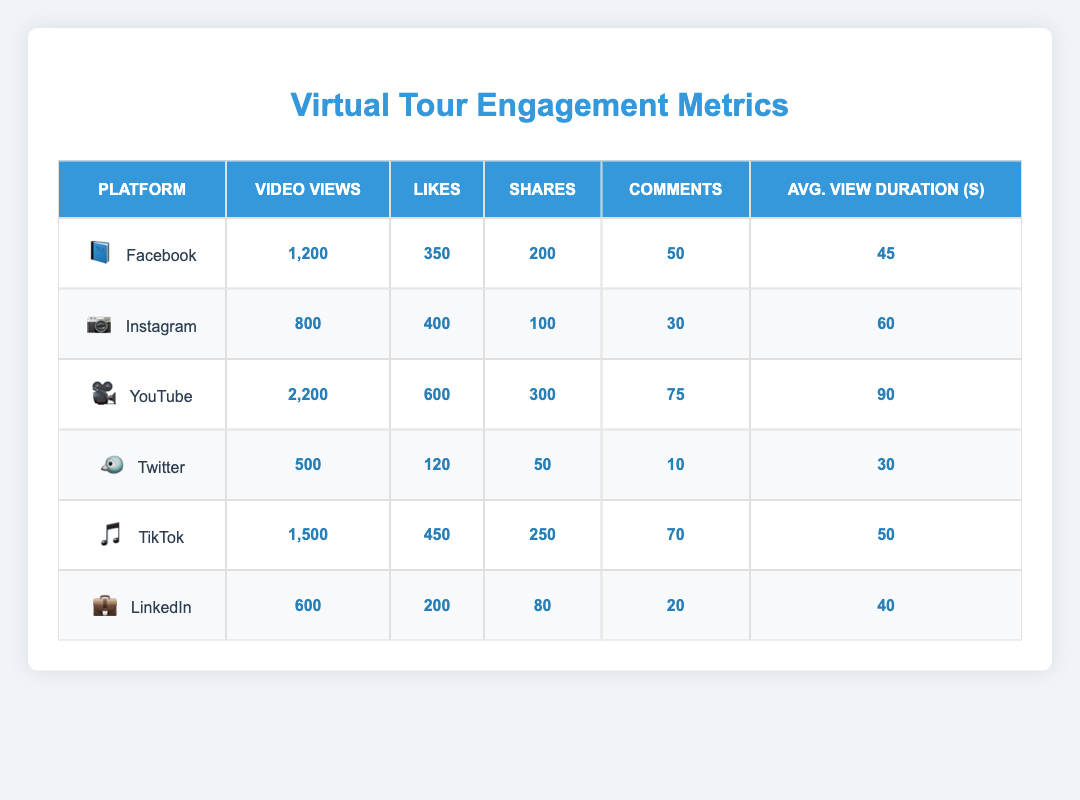What platform has the highest number of video views? By reviewing the video views for each platform listed in the table, YouTube has the highest value at 2,200 views.
Answer: YouTube What is the total number of likes across all platforms? Adding up the likes from all platforms: 350 + 400 + 600 + 120 + 450 + 200 = 2220.
Answer: 2220 Which platform has the lowest average view duration? Looking at the average view duration column, Twitter has the lowest value at 30 seconds.
Answer: Twitter How many shares does TikTok have compared to Instagram? TikTok has 250 shares and Instagram has 100 shares. The difference is 250 - 100 = 150 shares more for TikTok.
Answer: 150 more shares What is the average number of comments for all platforms combined? First, add the number of comments: 50 + 30 + 75 + 10 + 70 + 20 = 255. Then divide by the number of platforms (6): 255 / 6 = 42.5.
Answer: 42.5 Does Facebook have more likes than LinkedIn? Facebook has 350 likes while LinkedIn has 200. Since 350 is greater than 200, the answer is yes.
Answer: Yes Which platform has the highest ratio of likes to video views? Calculate the ratio for each platform: Facebook (350/1200), Instagram (400/800), YouTube (600/2200), Twitter (120/500), TikTok (450/1500), LinkedIn (200/600). After evaluating all, TikTok has the highest ratio of 0.3 (450/1500).
Answer: TikTok How does the average view duration of YouTube compare to that of Twitter? YouTube has an average view duration of 90 seconds and Twitter has 30 seconds. Comparing these values shows that YouTube's average is 60 seconds longer.
Answer: 60 seconds longer Which platform has the most shares compared to the others? By checking the shares column, YouTube has 300 shares, which is higher than all other platforms.
Answer: YouTube What is the total number of video views for Instagram and LinkedIn combined? Adding both values together: 800 (Instagram) + 600 (LinkedIn) = 1400.
Answer: 1400 Is the average view duration for TikTok higher than that of Facebook? TikTok has an average view duration of 50 seconds and Facebook has 45 seconds. Since 50 is greater than 45, the answer is yes.
Answer: Yes 